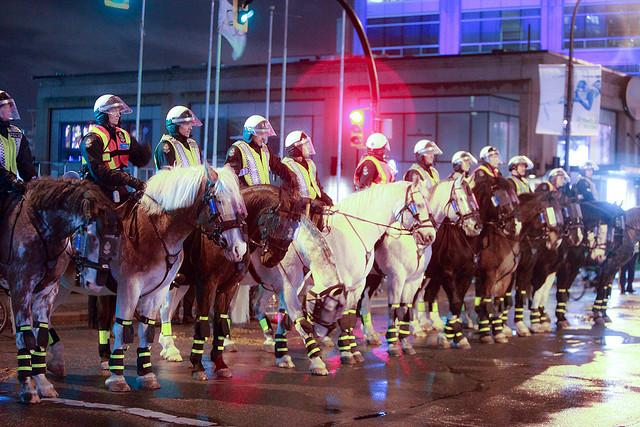What do the officers here observe? protest 